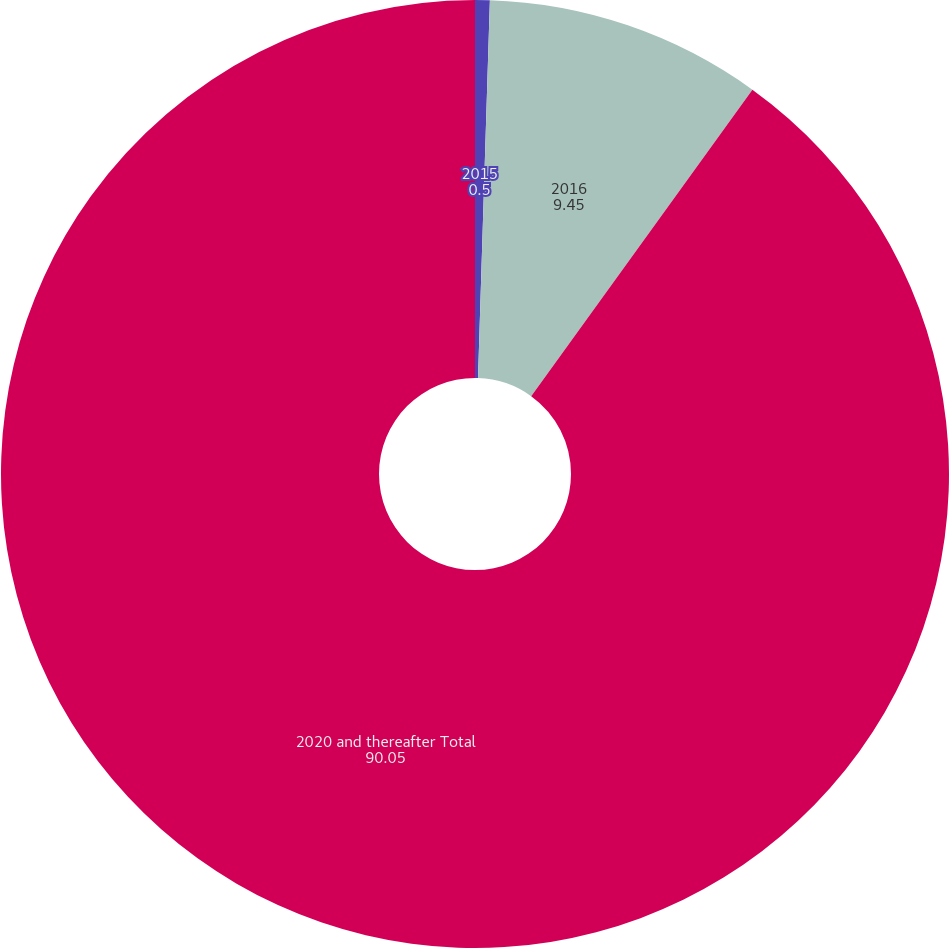Convert chart to OTSL. <chart><loc_0><loc_0><loc_500><loc_500><pie_chart><fcel>2015<fcel>2016<fcel>2020 and thereafter Total<nl><fcel>0.5%<fcel>9.45%<fcel>90.05%<nl></chart> 